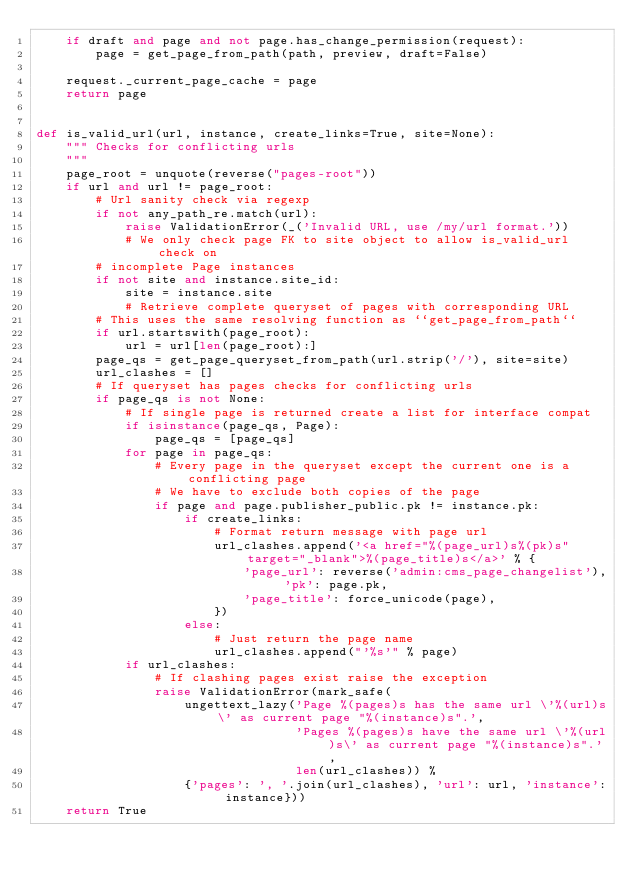<code> <loc_0><loc_0><loc_500><loc_500><_Python_>    if draft and page and not page.has_change_permission(request):
        page = get_page_from_path(path, preview, draft=False)

    request._current_page_cache = page
    return page


def is_valid_url(url, instance, create_links=True, site=None):
    """ Checks for conflicting urls
    """
    page_root = unquote(reverse("pages-root"))
    if url and url != page_root:
        # Url sanity check via regexp
        if not any_path_re.match(url):
            raise ValidationError(_('Invalid URL, use /my/url format.'))
            # We only check page FK to site object to allow is_valid_url check on
        # incomplete Page instances
        if not site and instance.site_id:
            site = instance.site
            # Retrieve complete queryset of pages with corresponding URL
        # This uses the same resolving function as ``get_page_from_path``
        if url.startswith(page_root):
            url = url[len(page_root):]
        page_qs = get_page_queryset_from_path(url.strip('/'), site=site)
        url_clashes = []
        # If queryset has pages checks for conflicting urls
        if page_qs is not None:
            # If single page is returned create a list for interface compat
            if isinstance(page_qs, Page):
                page_qs = [page_qs]
            for page in page_qs:
                # Every page in the queryset except the current one is a conflicting page
                # We have to exclude both copies of the page
                if page and page.publisher_public.pk != instance.pk:
                    if create_links:
                        # Format return message with page url
                        url_clashes.append('<a href="%(page_url)s%(pk)s" target="_blank">%(page_title)s</a>' % {
                            'page_url': reverse('admin:cms_page_changelist'), 'pk': page.pk,
                            'page_title': force_unicode(page),
                        })
                    else:
                        # Just return the page name
                        url_clashes.append("'%s'" % page)
            if url_clashes:
                # If clashing pages exist raise the exception
                raise ValidationError(mark_safe(
                    ungettext_lazy('Page %(pages)s has the same url \'%(url)s\' as current page "%(instance)s".',
                                   'Pages %(pages)s have the same url \'%(url)s\' as current page "%(instance)s".',
                                   len(url_clashes)) %
                    {'pages': ', '.join(url_clashes), 'url': url, 'instance': instance}))
    return True
</code> 